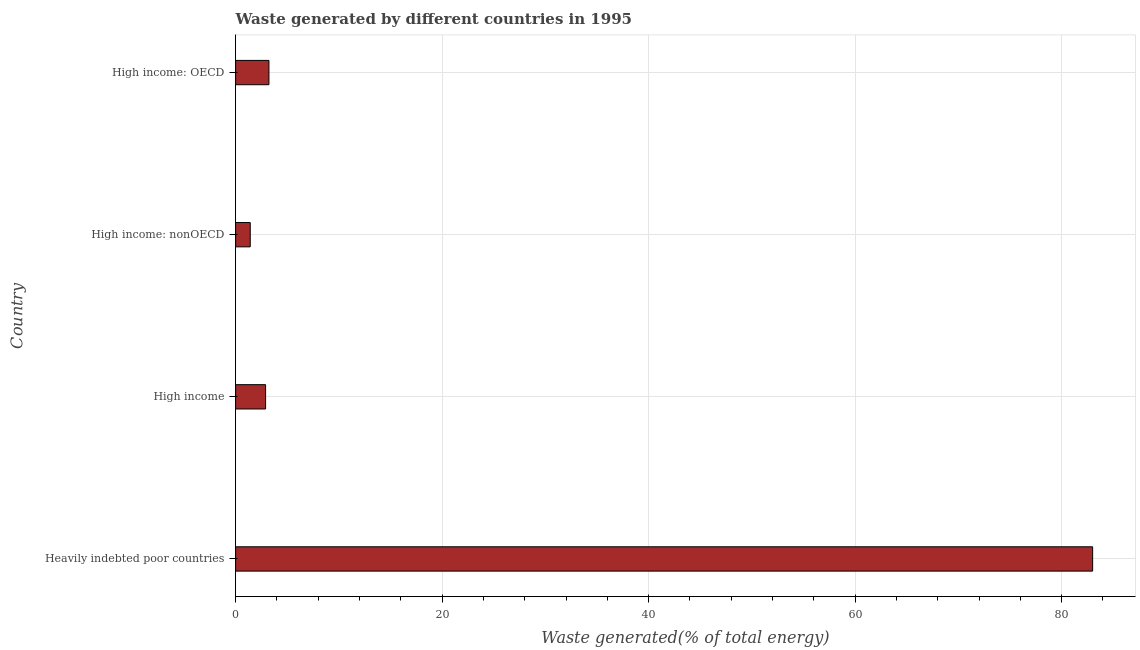Does the graph contain grids?
Provide a succinct answer. Yes. What is the title of the graph?
Make the answer very short. Waste generated by different countries in 1995. What is the label or title of the X-axis?
Offer a very short reply. Waste generated(% of total energy). What is the label or title of the Y-axis?
Provide a succinct answer. Country. What is the amount of waste generated in High income: nonOECD?
Keep it short and to the point. 1.42. Across all countries, what is the maximum amount of waste generated?
Ensure brevity in your answer.  83. Across all countries, what is the minimum amount of waste generated?
Keep it short and to the point. 1.42. In which country was the amount of waste generated maximum?
Your answer should be compact. Heavily indebted poor countries. In which country was the amount of waste generated minimum?
Offer a terse response. High income: nonOECD. What is the sum of the amount of waste generated?
Your answer should be compact. 90.55. What is the difference between the amount of waste generated in Heavily indebted poor countries and High income: nonOECD?
Provide a succinct answer. 81.58. What is the average amount of waste generated per country?
Ensure brevity in your answer.  22.64. What is the median amount of waste generated?
Give a very brief answer. 3.06. What is the ratio of the amount of waste generated in Heavily indebted poor countries to that in High income: OECD?
Offer a very short reply. 25.72. Is the difference between the amount of waste generated in Heavily indebted poor countries and High income: nonOECD greater than the difference between any two countries?
Ensure brevity in your answer.  Yes. What is the difference between the highest and the second highest amount of waste generated?
Give a very brief answer. 79.77. What is the difference between the highest and the lowest amount of waste generated?
Your answer should be compact. 81.58. In how many countries, is the amount of waste generated greater than the average amount of waste generated taken over all countries?
Provide a succinct answer. 1. How many bars are there?
Your response must be concise. 4. Are all the bars in the graph horizontal?
Offer a very short reply. Yes. How many countries are there in the graph?
Make the answer very short. 4. What is the difference between two consecutive major ticks on the X-axis?
Your answer should be very brief. 20. What is the Waste generated(% of total energy) in Heavily indebted poor countries?
Your response must be concise. 83. What is the Waste generated(% of total energy) in High income?
Offer a very short reply. 2.9. What is the Waste generated(% of total energy) of High income: nonOECD?
Keep it short and to the point. 1.42. What is the Waste generated(% of total energy) of High income: OECD?
Your response must be concise. 3.23. What is the difference between the Waste generated(% of total energy) in Heavily indebted poor countries and High income?
Your response must be concise. 80.1. What is the difference between the Waste generated(% of total energy) in Heavily indebted poor countries and High income: nonOECD?
Give a very brief answer. 81.58. What is the difference between the Waste generated(% of total energy) in Heavily indebted poor countries and High income: OECD?
Provide a succinct answer. 79.77. What is the difference between the Waste generated(% of total energy) in High income and High income: nonOECD?
Your response must be concise. 1.49. What is the difference between the Waste generated(% of total energy) in High income and High income: OECD?
Provide a short and direct response. -0.32. What is the difference between the Waste generated(% of total energy) in High income: nonOECD and High income: OECD?
Your response must be concise. -1.81. What is the ratio of the Waste generated(% of total energy) in Heavily indebted poor countries to that in High income?
Your response must be concise. 28.59. What is the ratio of the Waste generated(% of total energy) in Heavily indebted poor countries to that in High income: nonOECD?
Offer a very short reply. 58.62. What is the ratio of the Waste generated(% of total energy) in Heavily indebted poor countries to that in High income: OECD?
Your answer should be compact. 25.72. What is the ratio of the Waste generated(% of total energy) in High income to that in High income: nonOECD?
Provide a succinct answer. 2.05. What is the ratio of the Waste generated(% of total energy) in High income to that in High income: OECD?
Keep it short and to the point. 0.9. What is the ratio of the Waste generated(% of total energy) in High income: nonOECD to that in High income: OECD?
Keep it short and to the point. 0.44. 